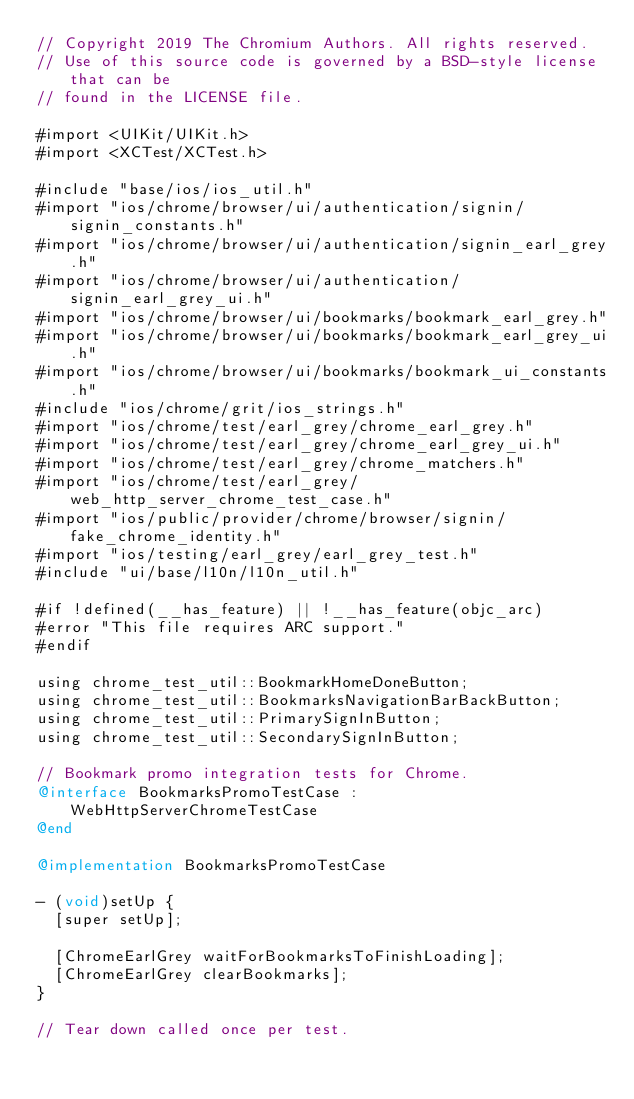<code> <loc_0><loc_0><loc_500><loc_500><_ObjectiveC_>// Copyright 2019 The Chromium Authors. All rights reserved.
// Use of this source code is governed by a BSD-style license that can be
// found in the LICENSE file.

#import <UIKit/UIKit.h>
#import <XCTest/XCTest.h>

#include "base/ios/ios_util.h"
#import "ios/chrome/browser/ui/authentication/signin/signin_constants.h"
#import "ios/chrome/browser/ui/authentication/signin_earl_grey.h"
#import "ios/chrome/browser/ui/authentication/signin_earl_grey_ui.h"
#import "ios/chrome/browser/ui/bookmarks/bookmark_earl_grey.h"
#import "ios/chrome/browser/ui/bookmarks/bookmark_earl_grey_ui.h"
#import "ios/chrome/browser/ui/bookmarks/bookmark_ui_constants.h"
#include "ios/chrome/grit/ios_strings.h"
#import "ios/chrome/test/earl_grey/chrome_earl_grey.h"
#import "ios/chrome/test/earl_grey/chrome_earl_grey_ui.h"
#import "ios/chrome/test/earl_grey/chrome_matchers.h"
#import "ios/chrome/test/earl_grey/web_http_server_chrome_test_case.h"
#import "ios/public/provider/chrome/browser/signin/fake_chrome_identity.h"
#import "ios/testing/earl_grey/earl_grey_test.h"
#include "ui/base/l10n/l10n_util.h"

#if !defined(__has_feature) || !__has_feature(objc_arc)
#error "This file requires ARC support."
#endif

using chrome_test_util::BookmarkHomeDoneButton;
using chrome_test_util::BookmarksNavigationBarBackButton;
using chrome_test_util::PrimarySignInButton;
using chrome_test_util::SecondarySignInButton;

// Bookmark promo integration tests for Chrome.
@interface BookmarksPromoTestCase : WebHttpServerChromeTestCase
@end

@implementation BookmarksPromoTestCase

- (void)setUp {
  [super setUp];

  [ChromeEarlGrey waitForBookmarksToFinishLoading];
  [ChromeEarlGrey clearBookmarks];
}

// Tear down called once per test.</code> 